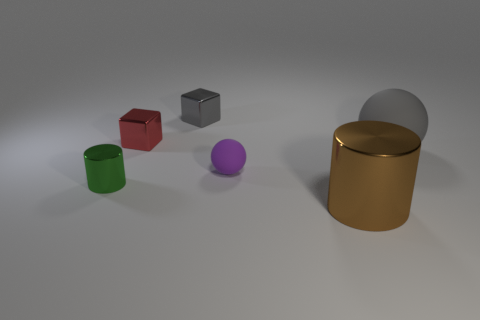Add 3 big red objects. How many objects exist? 9 Subtract all blocks. How many objects are left? 4 Subtract all red objects. Subtract all brown things. How many objects are left? 4 Add 4 big metallic cylinders. How many big metallic cylinders are left? 5 Add 1 tiny green metal things. How many tiny green metal things exist? 2 Subtract 0 cyan balls. How many objects are left? 6 